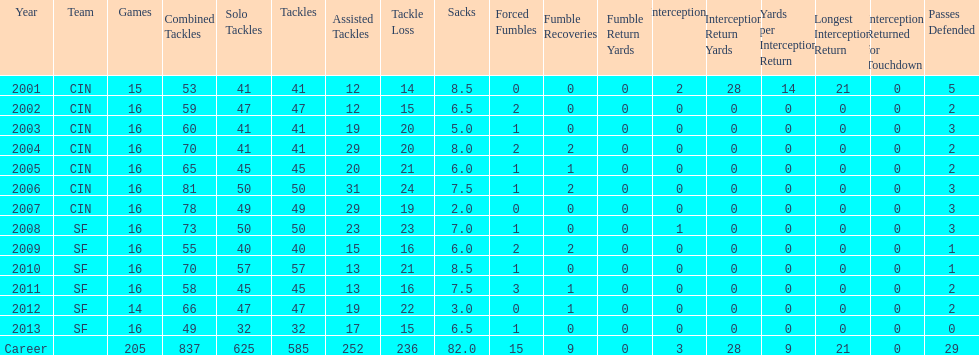How many consecutive seasons has he played sixteen games? 10. 